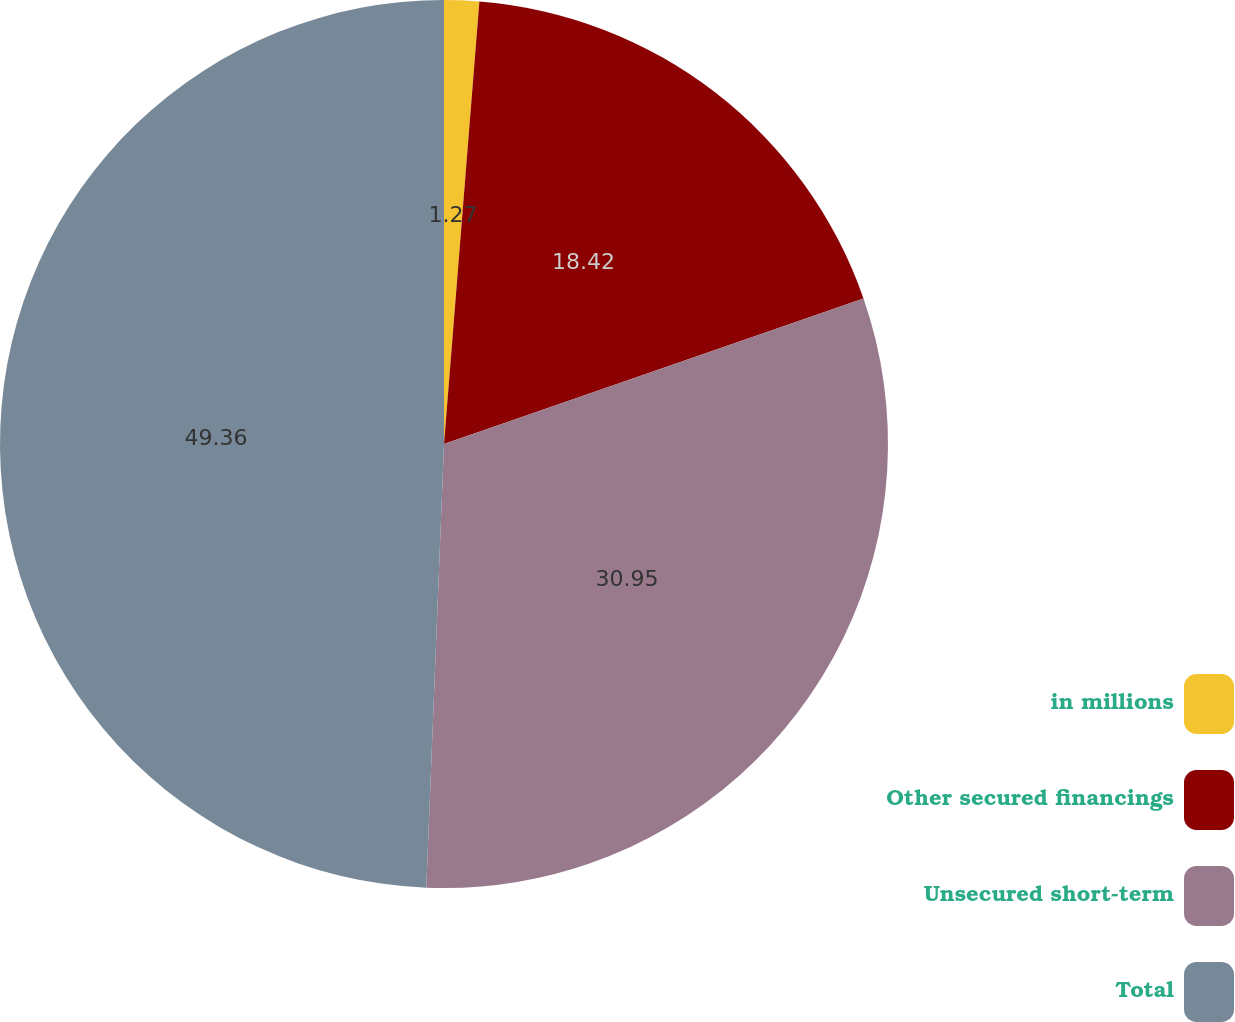<chart> <loc_0><loc_0><loc_500><loc_500><pie_chart><fcel>in millions<fcel>Other secured financings<fcel>Unsecured short-term<fcel>Total<nl><fcel>1.27%<fcel>18.42%<fcel>30.95%<fcel>49.37%<nl></chart> 